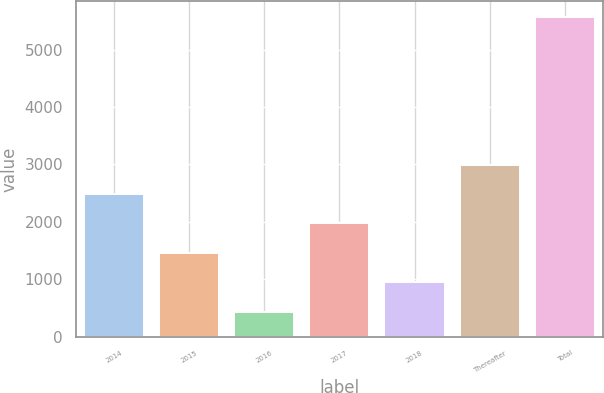Convert chart. <chart><loc_0><loc_0><loc_500><loc_500><bar_chart><fcel>2014<fcel>2015<fcel>2016<fcel>2017<fcel>2018<fcel>Thereafter<fcel>Total<nl><fcel>2485.28<fcel>1459.14<fcel>433<fcel>1972.21<fcel>946.07<fcel>2998.35<fcel>5563.7<nl></chart> 